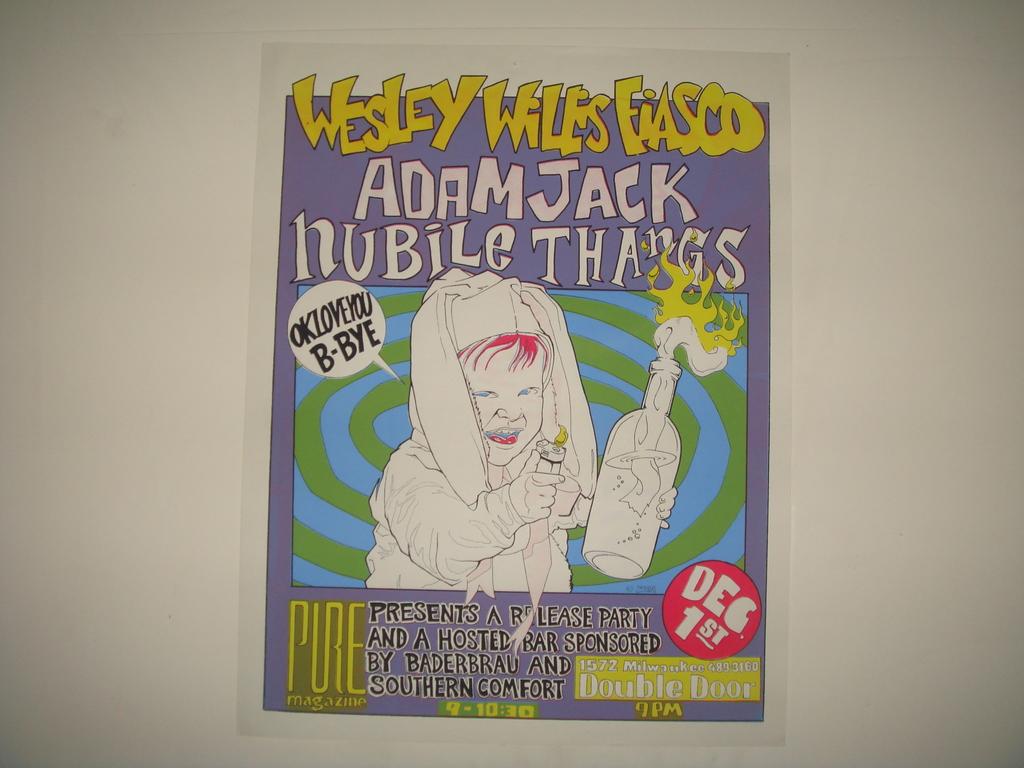What is the title of this comic?
Offer a terse response. Adam jack nubile thangs. When did this come out?
Ensure brevity in your answer.  Dec 1st. 